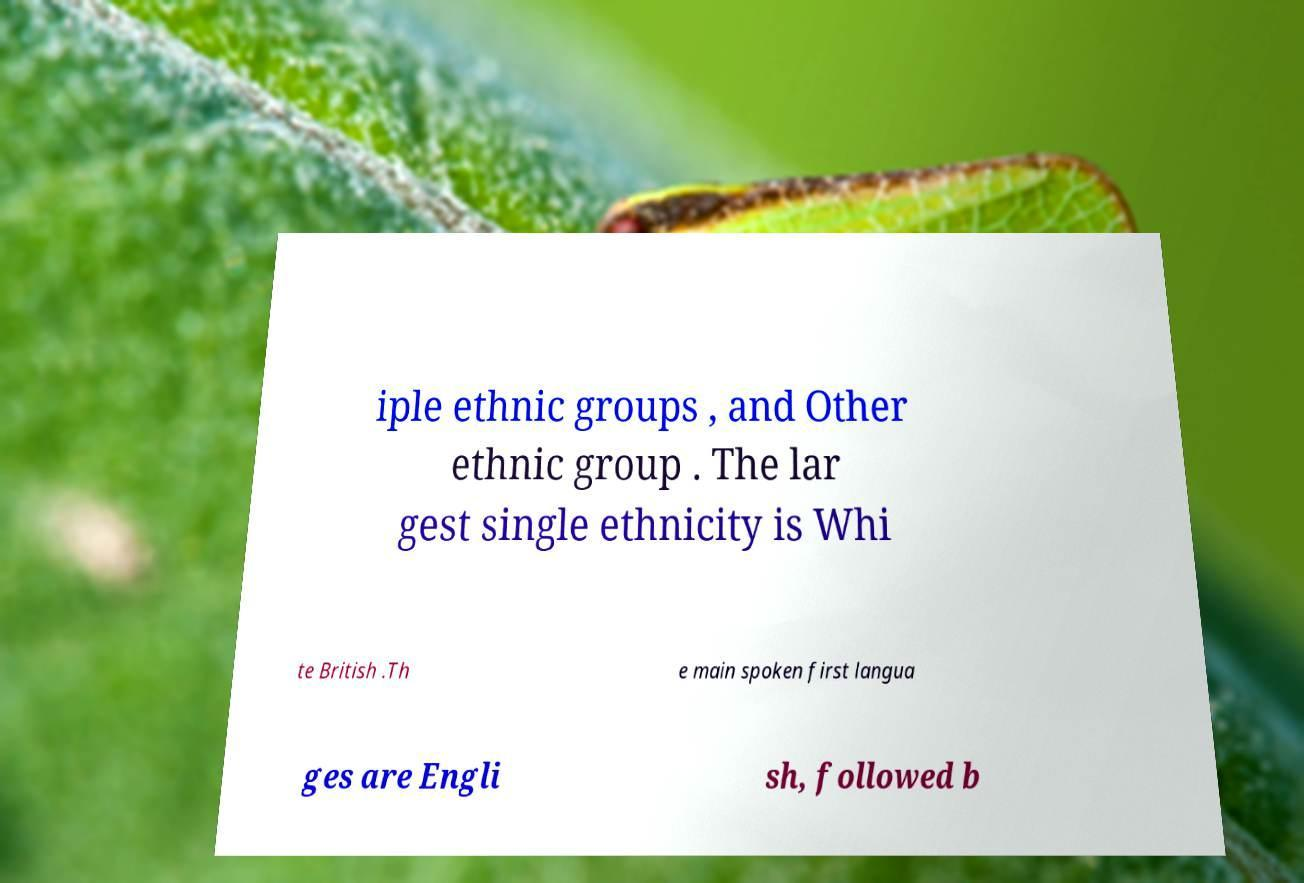Please read and relay the text visible in this image. What does it say? iple ethnic groups , and Other ethnic group . The lar gest single ethnicity is Whi te British .Th e main spoken first langua ges are Engli sh, followed b 